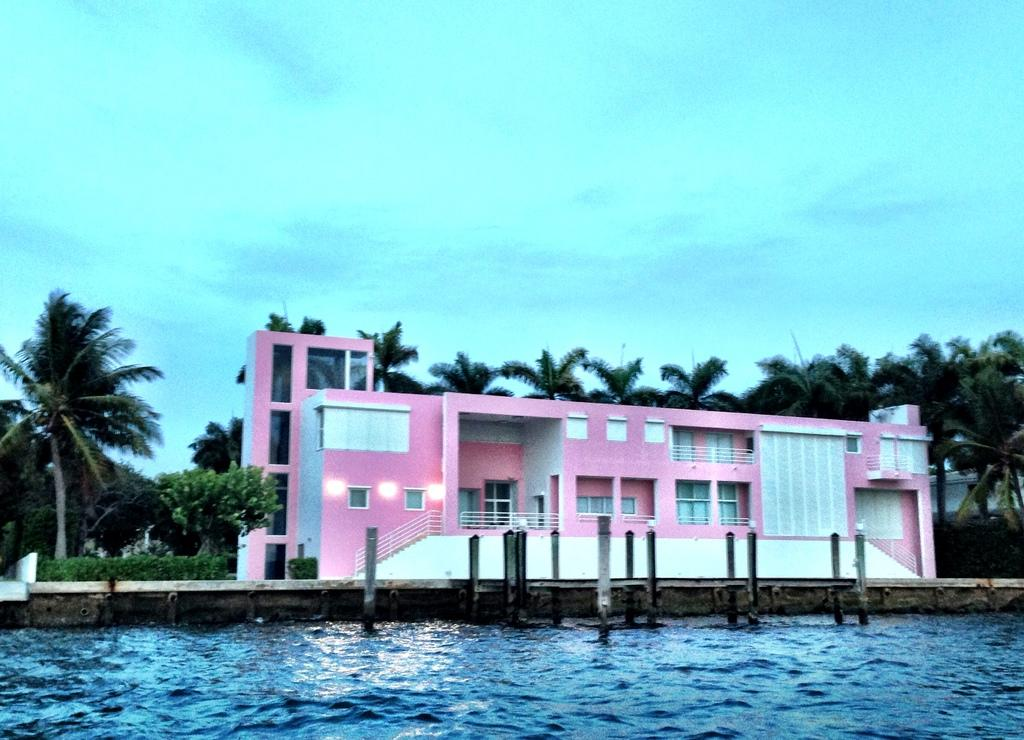What can be seen in the foreground of the image? There is water in the foreground of the image. What is located in the center of the image? There are plants, trees, palm trees, buildings, and a dock in the center of the image. Can you describe the trees in the image? The trees in the image include palm trees. What is the condition of the sky in the image? The sky is cloudy in the image. What is the income of the palm trees in the image? There is no income associated with the palm trees in the image, as they are not living beings with the ability to earn money. What flavor do the buildings have in the image? There is no mention of flavor in the image, as it pertains to buildings or any other subject in the image. 